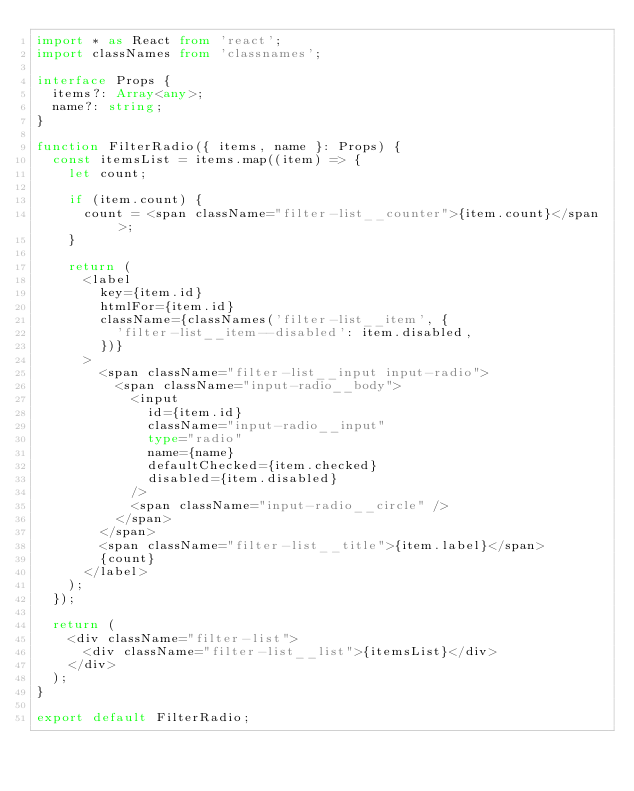Convert code to text. <code><loc_0><loc_0><loc_500><loc_500><_TypeScript_>import * as React from 'react';
import classNames from 'classnames';

interface Props {
  items?: Array<any>;
  name?: string;
}

function FilterRadio({ items, name }: Props) {
  const itemsList = items.map((item) => {
    let count;

    if (item.count) {
      count = <span className="filter-list__counter">{item.count}</span>;
    }

    return (
      <label
        key={item.id}
        htmlFor={item.id}
        className={classNames('filter-list__item', {
          'filter-list__item--disabled': item.disabled,
        })}
      >
        <span className="filter-list__input input-radio">
          <span className="input-radio__body">
            <input
              id={item.id}
              className="input-radio__input"
              type="radio"
              name={name}
              defaultChecked={item.checked}
              disabled={item.disabled}
            />
            <span className="input-radio__circle" />
          </span>
        </span>
        <span className="filter-list__title">{item.label}</span>
        {count}
      </label>
    );
  });

  return (
    <div className="filter-list">
      <div className="filter-list__list">{itemsList}</div>
    </div>
  );
}

export default FilterRadio;
</code> 